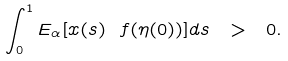Convert formula to latex. <formula><loc_0><loc_0><loc_500><loc_500>\int _ { 0 } ^ { 1 } E _ { \alpha } [ x ( s ) \ f ( \eta ( 0 ) ) ] d s \ > \ 0 .</formula> 